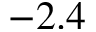<formula> <loc_0><loc_0><loc_500><loc_500>- 2 . 4</formula> 